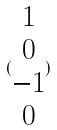<formula> <loc_0><loc_0><loc_500><loc_500>( \begin{matrix} 1 \\ 0 \\ - 1 \\ 0 \end{matrix} )</formula> 